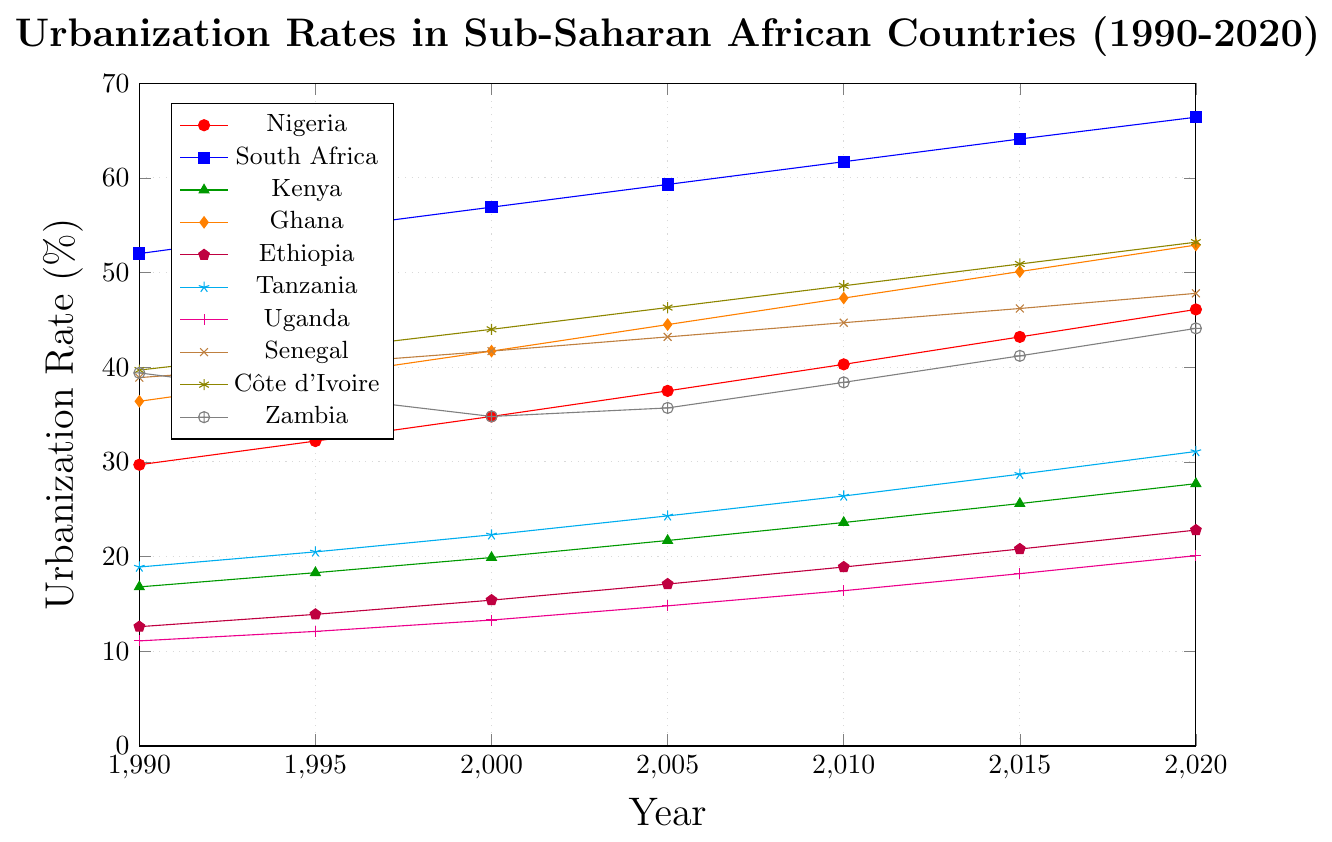What is the urbanization rate of South Africa in 2020? Identify the line corresponding to South Africa (blue line with square markers) and read the value for the year 2020 on the x-axis, which corresponds to 66.4%.
Answer: 66.4% Which country had the lowest urbanization rate in 1990? Look at the points on the figure for the year 1990 and identify the lowest point among all the lines. Ethiopia (purple line with pentagon markers) had the lowest rate at 12.6%.
Answer: Ethiopia Between which years did Nigeria see the highest rate of increase in urbanization? Identify the steepest segment of the Nigeria line (red line with circle markers). The segment between 1990 (29.7%) and 2020 (46.1%) shows a continuous increase, but the highest period of growth appears between 2015 (43.2%) and 2020 (46.1%).
Answer: 2015 to 2020 How much did the urbanization rate of Zambia change between 1990 and 2000? Find the value of Zambia (gray line with oplus markers) in 1990 (39.4%) and 2000 (34.8%), then compute the difference: 39.4 - 34.8 = 4.6%.
Answer: 4.6% Which country had the highest urbanization rate in 1995, and what was it? Compare the points for the year 1995 on the x-axis for all countries. South Africa (blue line with square markers) had the highest rate at 54.5%.
Answer: South Africa, 54.5% Compare the urbanization rates of Kenya and Tanzania in 2015. Which one was higher and by how much? Check the values of Kenya (green line with triangle markers) and Tanzania (cyan line with star markers) in 2015. Kenya was at 25.6% and Tanzania at 28.7%. The difference is 28.7 - 25.6 = 3.1%.
Answer: Tanzania, 3.1% Which country had a greater increase in urbanization rate from 2005 to 2010, Senegal or Côte d'Ivoire? Determine the values for Senegal (brown line with x markers) and Côte d'Ivoire (olive line with asterisk markers) in 2005 and 2010. For Senegal: 2010 (44.7%) - 2005 (43.2%) = 1.5%. For Côte d'Ivoire: 2010 (48.6%) - 2005 (46.3%) = 2.3%. Côte d'Ivoire had a greater increase.
Answer: Côte d'Ivoire What is the average urbanization rate of Ghana from 1990 to 2020? Add up Ghana's urbanization rates for each year and divide by the number of data points: (36.4 + 39.0 + 41.7 + 44.5 + 47.3 + 50.1 + 52.9) / 7 = 44.27%. Round as needed.
Answer: 44.27% Which country has a nearly consistent upward trend without any dips from 1990 to 2020? Observe the lines for each country and note that South Africa (blue line with square markers) shows a consistent upward trend without any dips.
Answer: South Africa By how much did Uganda's urbanization rate increase between 1990 and 2020? Determine Uganda's values in 1990 (11.1%) and 2020 (20.1%) and calculate the difference: 20.1 - 11.1 = 9%.
Answer: 9% 